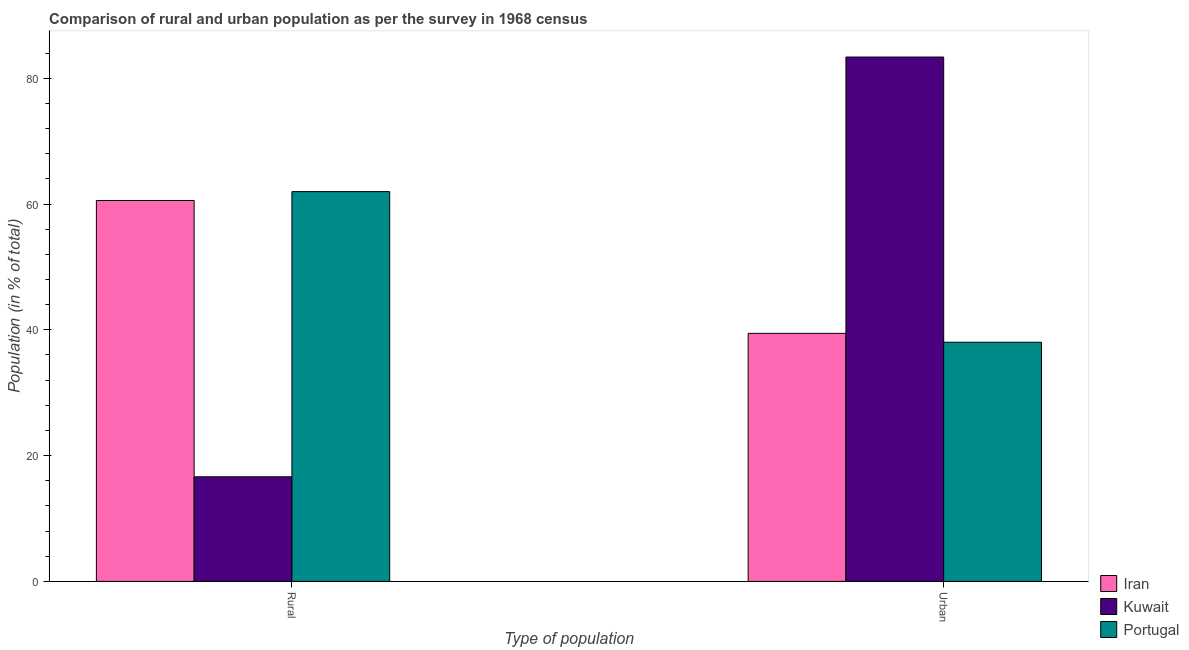How many different coloured bars are there?
Make the answer very short. 3. How many groups of bars are there?
Offer a very short reply. 2. Are the number of bars on each tick of the X-axis equal?
Your answer should be very brief. Yes. How many bars are there on the 1st tick from the right?
Provide a short and direct response. 3. What is the label of the 2nd group of bars from the left?
Make the answer very short. Urban. What is the rural population in Iran?
Keep it short and to the point. 60.56. Across all countries, what is the maximum urban population?
Give a very brief answer. 83.37. Across all countries, what is the minimum urban population?
Provide a short and direct response. 38.02. In which country was the urban population maximum?
Ensure brevity in your answer.  Kuwait. What is the total urban population in the graph?
Keep it short and to the point. 160.83. What is the difference between the rural population in Portugal and that in Kuwait?
Provide a short and direct response. 45.35. What is the difference between the urban population in Portugal and the rural population in Iran?
Ensure brevity in your answer.  -22.54. What is the average urban population per country?
Keep it short and to the point. 53.61. What is the difference between the rural population and urban population in Iran?
Offer a terse response. 21.13. In how many countries, is the urban population greater than 16 %?
Your response must be concise. 3. What is the ratio of the rural population in Iran to that in Portugal?
Make the answer very short. 0.98. Is the urban population in Kuwait less than that in Iran?
Your answer should be very brief. No. In how many countries, is the urban population greater than the average urban population taken over all countries?
Make the answer very short. 1. What does the 2nd bar from the left in Rural represents?
Provide a short and direct response. Kuwait. Are all the bars in the graph horizontal?
Offer a very short reply. No. Does the graph contain grids?
Provide a succinct answer. No. How many legend labels are there?
Provide a short and direct response. 3. What is the title of the graph?
Your answer should be compact. Comparison of rural and urban population as per the survey in 1968 census. What is the label or title of the X-axis?
Your response must be concise. Type of population. What is the label or title of the Y-axis?
Keep it short and to the point. Population (in % of total). What is the Population (in % of total) of Iran in Rural?
Keep it short and to the point. 60.56. What is the Population (in % of total) in Kuwait in Rural?
Provide a short and direct response. 16.63. What is the Population (in % of total) of Portugal in Rural?
Keep it short and to the point. 61.98. What is the Population (in % of total) of Iran in Urban?
Provide a succinct answer. 39.44. What is the Population (in % of total) in Kuwait in Urban?
Ensure brevity in your answer.  83.37. What is the Population (in % of total) in Portugal in Urban?
Offer a very short reply. 38.02. Across all Type of population, what is the maximum Population (in % of total) in Iran?
Make the answer very short. 60.56. Across all Type of population, what is the maximum Population (in % of total) of Kuwait?
Give a very brief answer. 83.37. Across all Type of population, what is the maximum Population (in % of total) of Portugal?
Provide a short and direct response. 61.98. Across all Type of population, what is the minimum Population (in % of total) in Iran?
Offer a terse response. 39.44. Across all Type of population, what is the minimum Population (in % of total) in Kuwait?
Make the answer very short. 16.63. Across all Type of population, what is the minimum Population (in % of total) in Portugal?
Provide a short and direct response. 38.02. What is the total Population (in % of total) of Portugal in the graph?
Your answer should be very brief. 100. What is the difference between the Population (in % of total) in Iran in Rural and that in Urban?
Your answer should be very brief. 21.13. What is the difference between the Population (in % of total) in Kuwait in Rural and that in Urban?
Your answer should be very brief. -66.74. What is the difference between the Population (in % of total) in Portugal in Rural and that in Urban?
Your answer should be compact. 23.95. What is the difference between the Population (in % of total) of Iran in Rural and the Population (in % of total) of Kuwait in Urban?
Your answer should be very brief. -22.81. What is the difference between the Population (in % of total) in Iran in Rural and the Population (in % of total) in Portugal in Urban?
Make the answer very short. 22.54. What is the difference between the Population (in % of total) in Kuwait in Rural and the Population (in % of total) in Portugal in Urban?
Make the answer very short. -21.4. What is the difference between the Population (in % of total) in Iran and Population (in % of total) in Kuwait in Rural?
Make the answer very short. 43.93. What is the difference between the Population (in % of total) of Iran and Population (in % of total) of Portugal in Rural?
Provide a succinct answer. -1.41. What is the difference between the Population (in % of total) of Kuwait and Population (in % of total) of Portugal in Rural?
Ensure brevity in your answer.  -45.35. What is the difference between the Population (in % of total) of Iran and Population (in % of total) of Kuwait in Urban?
Offer a terse response. -43.93. What is the difference between the Population (in % of total) in Iran and Population (in % of total) in Portugal in Urban?
Make the answer very short. 1.41. What is the difference between the Population (in % of total) in Kuwait and Population (in % of total) in Portugal in Urban?
Your response must be concise. 45.35. What is the ratio of the Population (in % of total) in Iran in Rural to that in Urban?
Your response must be concise. 1.54. What is the ratio of the Population (in % of total) in Kuwait in Rural to that in Urban?
Your response must be concise. 0.2. What is the ratio of the Population (in % of total) of Portugal in Rural to that in Urban?
Provide a short and direct response. 1.63. What is the difference between the highest and the second highest Population (in % of total) of Iran?
Offer a terse response. 21.13. What is the difference between the highest and the second highest Population (in % of total) in Kuwait?
Give a very brief answer. 66.74. What is the difference between the highest and the second highest Population (in % of total) in Portugal?
Give a very brief answer. 23.95. What is the difference between the highest and the lowest Population (in % of total) of Iran?
Provide a succinct answer. 21.13. What is the difference between the highest and the lowest Population (in % of total) of Kuwait?
Keep it short and to the point. 66.74. What is the difference between the highest and the lowest Population (in % of total) of Portugal?
Provide a short and direct response. 23.95. 